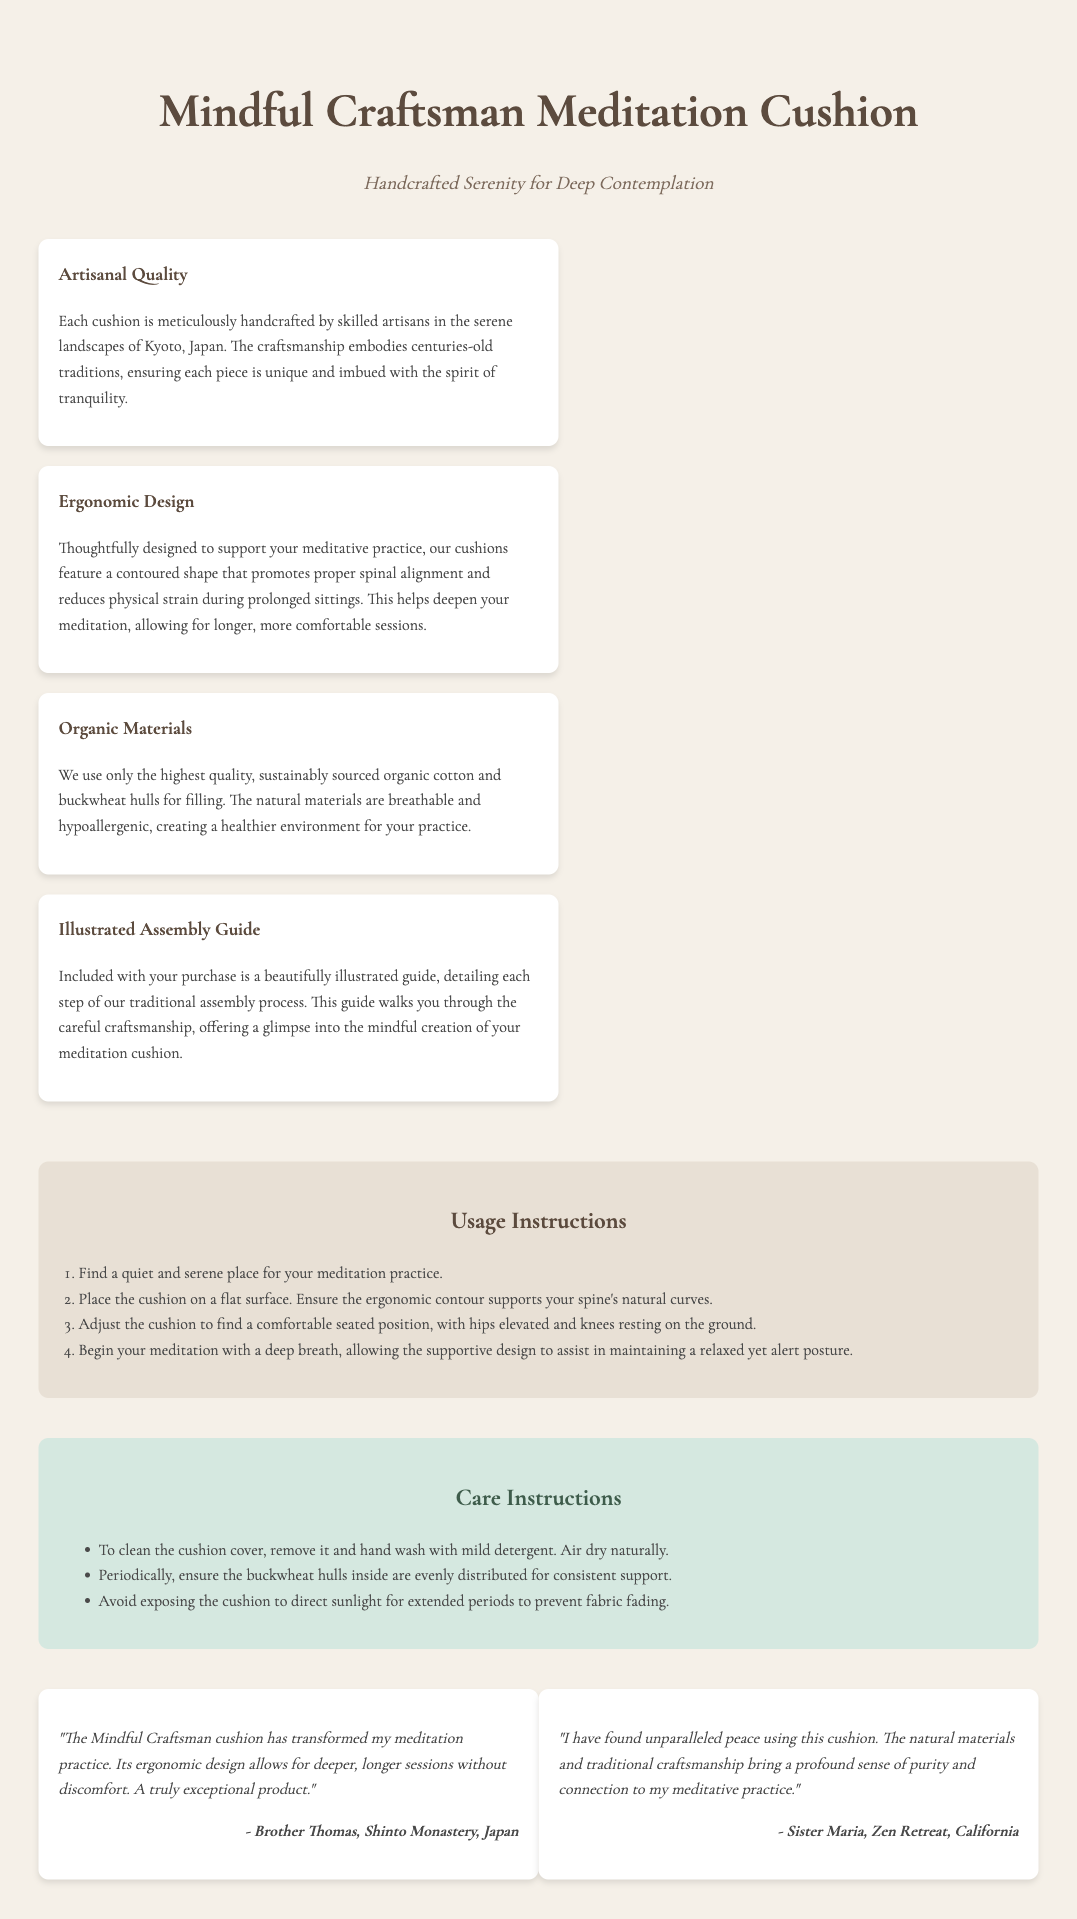What materials are used in the cushion? The cushion is made from sustainably sourced organic cotton and buckwheat hulls for filling.
Answer: Organic cotton and buckwheat hulls Where are the cushions handcrafted? The cushions are meticulously handcrafted by skilled artisans in a specific location.
Answer: Kyoto, Japan What feature promotes proper spinal alignment? The design aspect of the cushion that assists with spinal alignment is mentioned explicitly.
Answer: Ergonomic Design How many usage instructions are provided? The document outlines a specific number of steps involved in using the cushion.
Answer: Four What should you do to clean the cushion cover? The care instructions specify a method for cleaning the cushion cover.
Answer: Hand wash with mild detergent Which artisan is quoted in the testimonials? A specific individual from a particular religious community is mentioned in the testimonials.
Answer: Brother Thomas What do the buckwheat hulls provide? The purpose of the buckwheat hulls in the cushion is highlighted in a specific context.
Answer: Consistent support What type of guide is included with the cushion? The document describes the nature of the guide that comes with the product.
Answer: Illustrated guide 